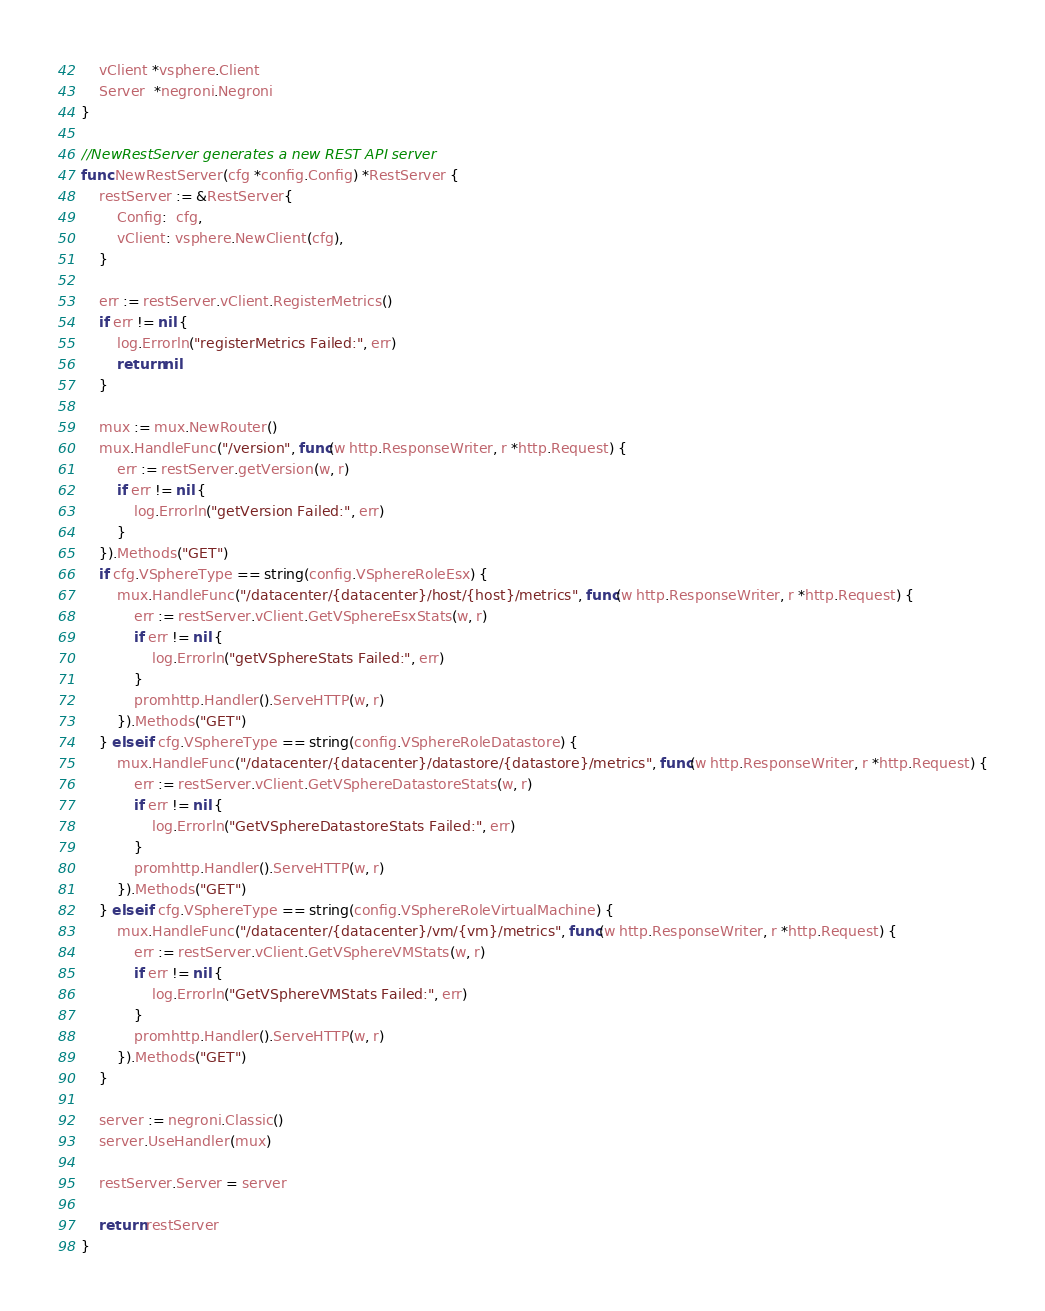<code> <loc_0><loc_0><loc_500><loc_500><_Go_>	vClient *vsphere.Client
	Server  *negroni.Negroni
}

//NewRestServer generates a new REST API server
func NewRestServer(cfg *config.Config) *RestServer {
	restServer := &RestServer{
		Config:  cfg,
		vClient: vsphere.NewClient(cfg),
	}

	err := restServer.vClient.RegisterMetrics()
	if err != nil {
		log.Errorln("registerMetrics Failed:", err)
		return nil
	}

	mux := mux.NewRouter()
	mux.HandleFunc("/version", func(w http.ResponseWriter, r *http.Request) {
		err := restServer.getVersion(w, r)
		if err != nil {
			log.Errorln("getVersion Failed:", err)
		}
	}).Methods("GET")
	if cfg.VSphereType == string(config.VSphereRoleEsx) {
		mux.HandleFunc("/datacenter/{datacenter}/host/{host}/metrics", func(w http.ResponseWriter, r *http.Request) {
			err := restServer.vClient.GetVSphereEsxStats(w, r)
			if err != nil {
				log.Errorln("getVSphereStats Failed:", err)
			}
			promhttp.Handler().ServeHTTP(w, r)
		}).Methods("GET")
	} else if cfg.VSphereType == string(config.VSphereRoleDatastore) {
		mux.HandleFunc("/datacenter/{datacenter}/datastore/{datastore}/metrics", func(w http.ResponseWriter, r *http.Request) {
			err := restServer.vClient.GetVSphereDatastoreStats(w, r)
			if err != nil {
				log.Errorln("GetVSphereDatastoreStats Failed:", err)
			}
			promhttp.Handler().ServeHTTP(w, r)
		}).Methods("GET")
	} else if cfg.VSphereType == string(config.VSphereRoleVirtualMachine) {
		mux.HandleFunc("/datacenter/{datacenter}/vm/{vm}/metrics", func(w http.ResponseWriter, r *http.Request) {
			err := restServer.vClient.GetVSphereVMStats(w, r)
			if err != nil {
				log.Errorln("GetVSphereVMStats Failed:", err)
			}
			promhttp.Handler().ServeHTTP(w, r)
		}).Methods("GET")
	}

	server := negroni.Classic()
	server.UseHandler(mux)

	restServer.Server = server

	return restServer
}
</code> 